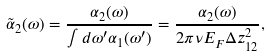Convert formula to latex. <formula><loc_0><loc_0><loc_500><loc_500>\tilde { \alpha } _ { 2 } ( \omega ) = \frac { \alpha _ { 2 } ( \omega ) } { \int d \omega ^ { \prime } \alpha _ { 1 } ( \omega ^ { \prime } ) } = \frac { \alpha _ { 2 } ( \omega ) } { 2 \pi \nu E _ { F } \Delta z _ { 1 2 } ^ { 2 } } ,</formula> 